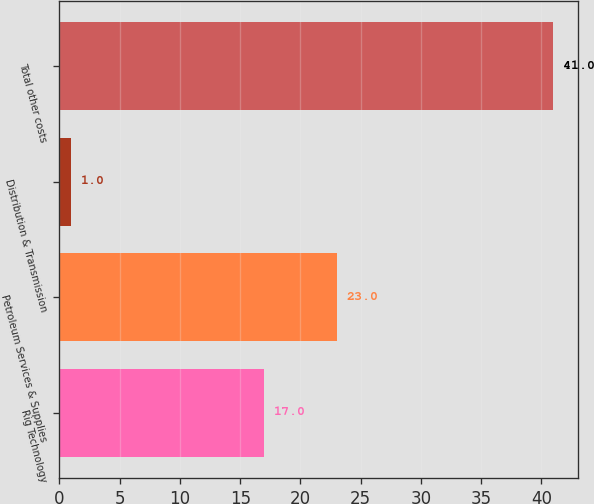Convert chart to OTSL. <chart><loc_0><loc_0><loc_500><loc_500><bar_chart><fcel>Rig Technology<fcel>Petroleum Services & Supplies<fcel>Distribution & Transmission<fcel>Total other costs<nl><fcel>17<fcel>23<fcel>1<fcel>41<nl></chart> 